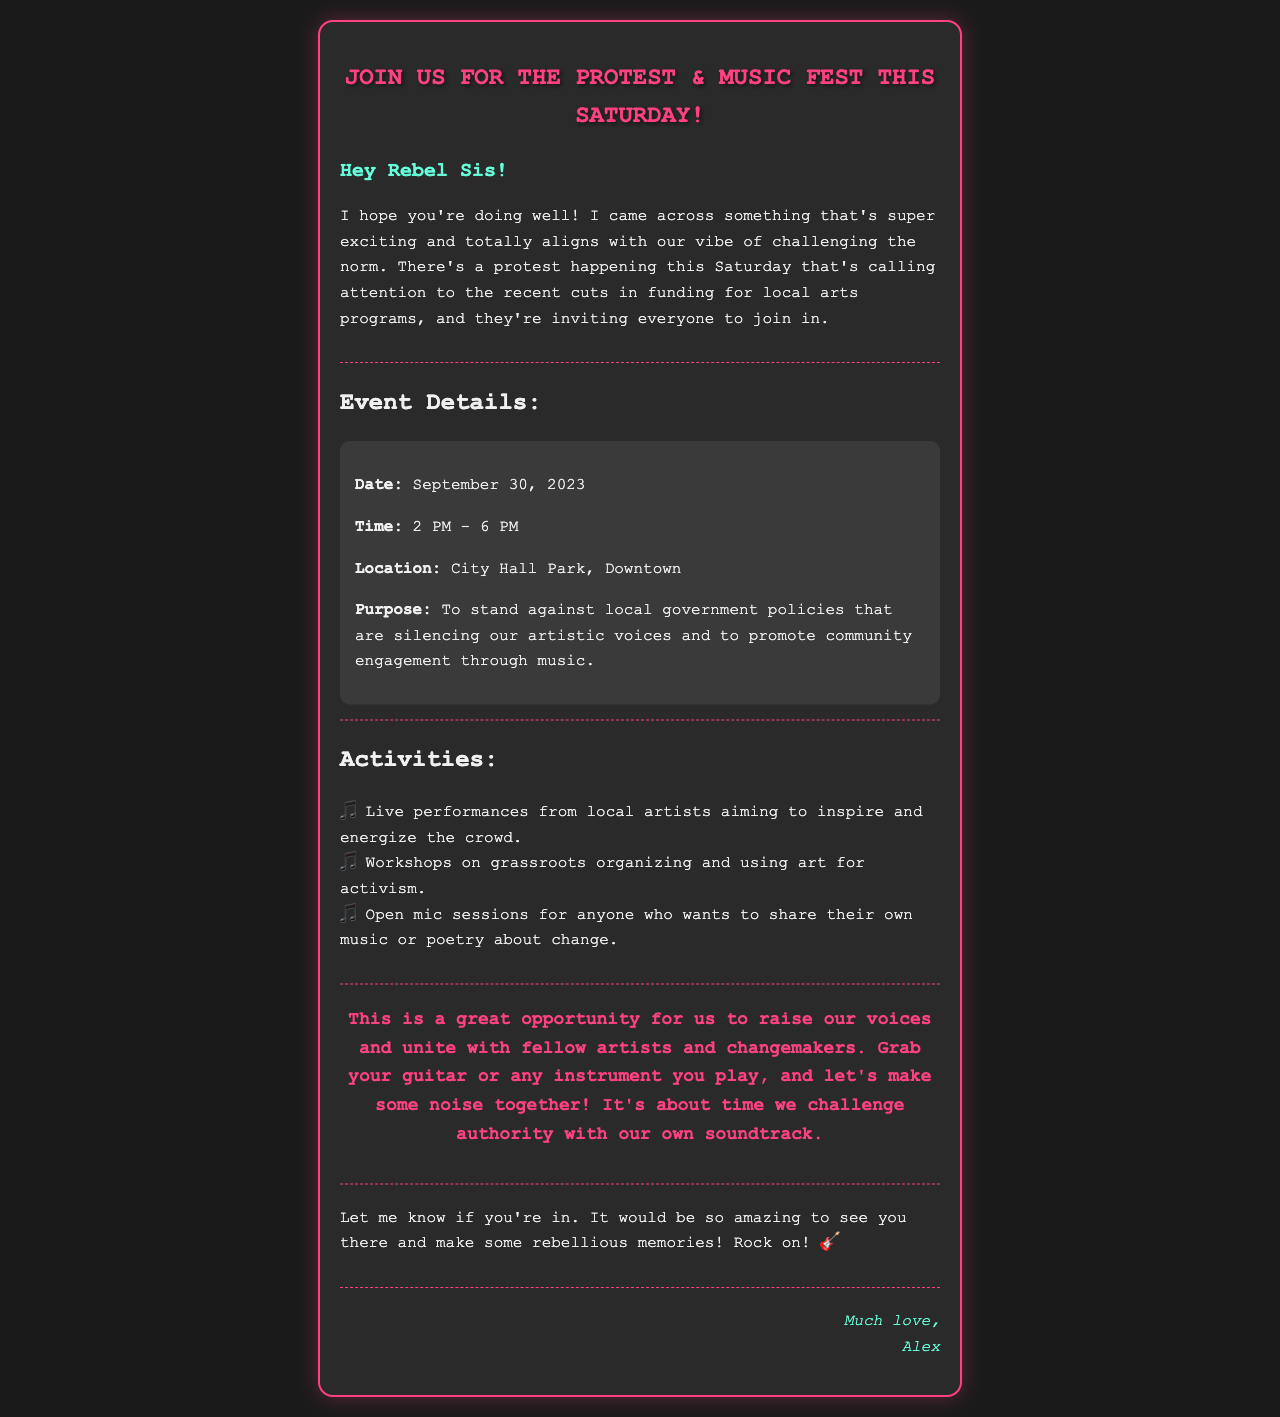What is the date of the protest? The document states that the protest is happening on September 30, 2023.
Answer: September 30, 2023 What time does the protest start? According to the email, the protest starts at 2 PM.
Answer: 2 PM Where is the protest taking place? The email specifies that the location of the protest is City Hall Park, Downtown.
Answer: City Hall Park, Downtown What is the main purpose of the protest? The main purpose, as described in the document, is to stand against local government policies that are silencing artistic voices.
Answer: To stand against local government policies What activities are included in the event? The document lists several activities including live performances, workshops, and open mic sessions.
Answer: Live performances, workshops, open mic sessions Who is sending the email? The email is signed off by Alex, who is the sender.
Answer: Alex What type of music event is mentioned? The event is described as a Music Fest, with live performances planned.
Answer: Music Fest What does the author encourage to bring to the protest? The author encourages participants to bring their guitar or any instrument they play.
Answer: Guitar or any instrument What sentiment does the email convey regarding authority? The email expresses a rebellious sentiment against authority, encouraging participants to challenge it through music.
Answer: Rebellious 